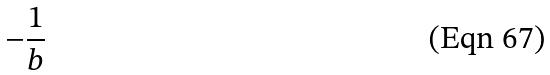Convert formula to latex. <formula><loc_0><loc_0><loc_500><loc_500>- \frac { 1 } { b }</formula> 